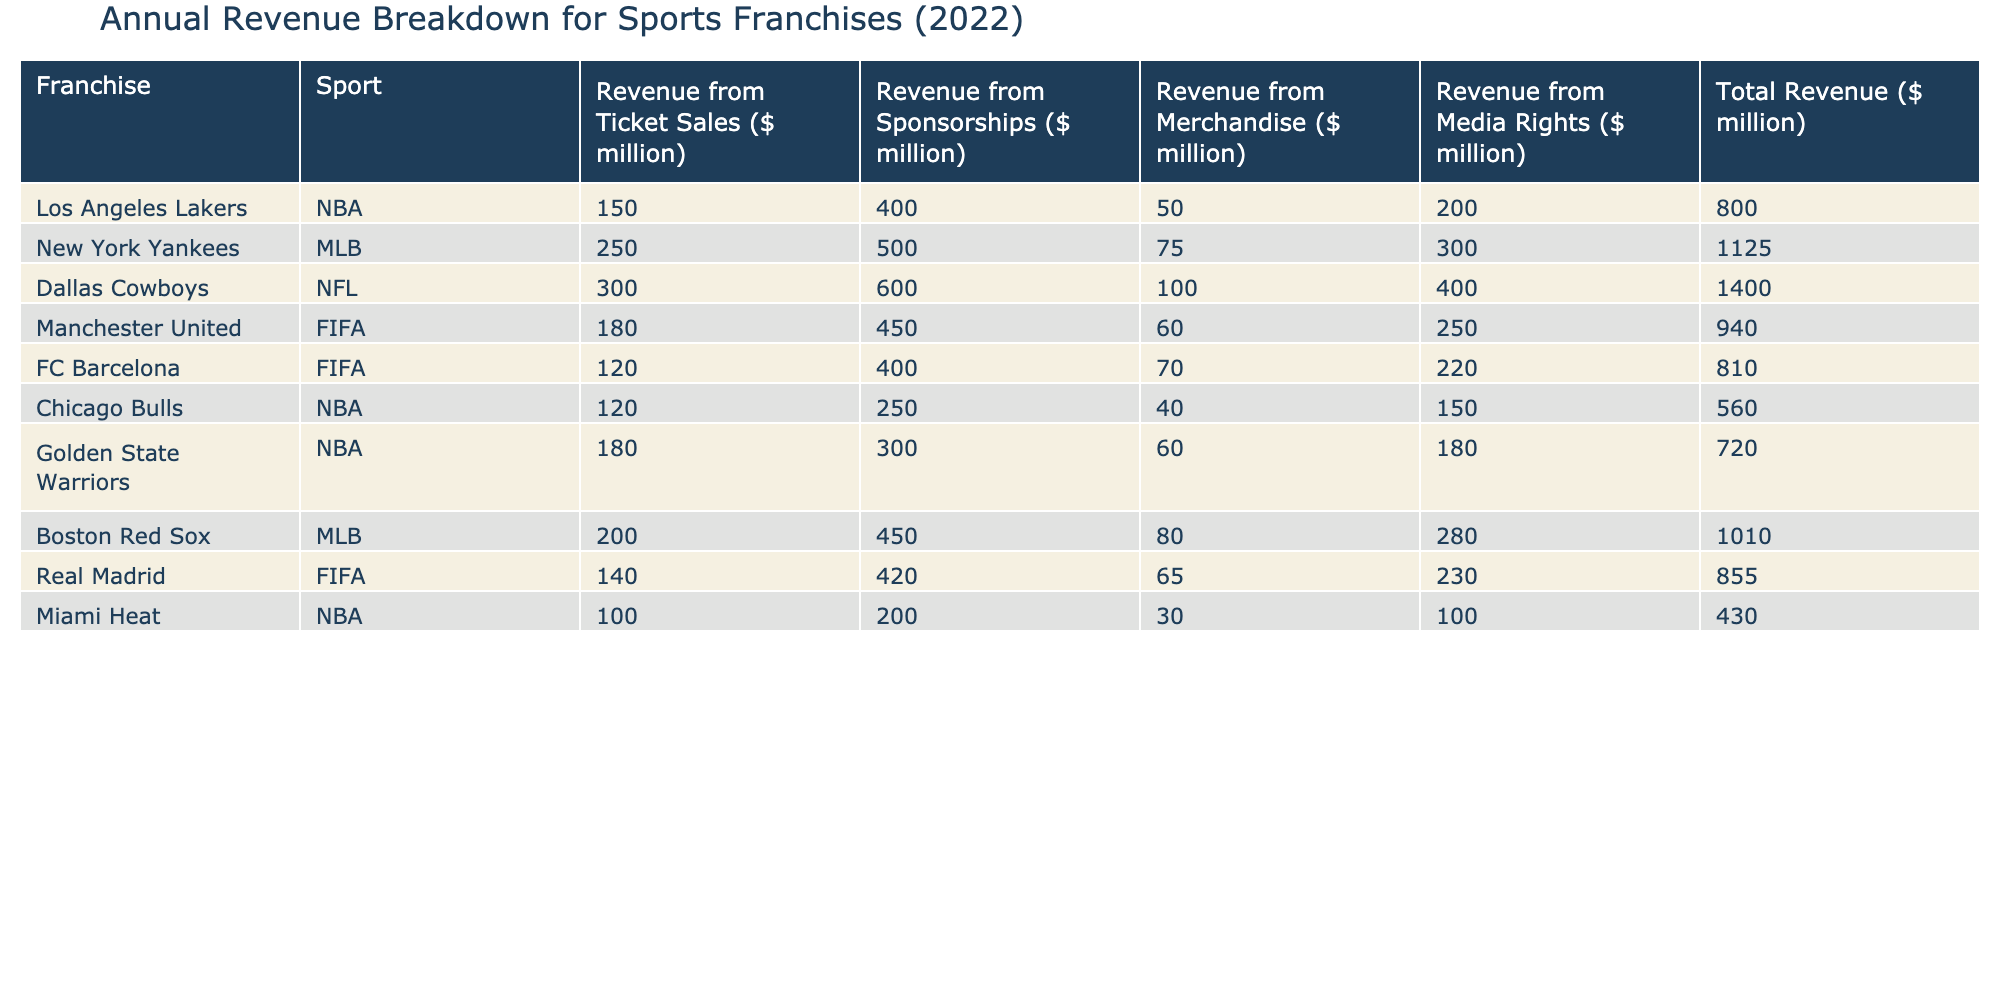What is the total revenue for the New York Yankees? The New York Yankees' total revenue is provided in the table under the column "Total Revenue," which shows it is 1125 million dollars.
Answer: 1125 million dollars Which franchise has the highest revenue from merchandise sales? By examining the "Revenue from Merchandise" column, the franchise with the highest value is the Boston Red Sox, with revenue of 80 million dollars.
Answer: Boston Red Sox What is the combined revenue from ticket sales for NBA franchises? The ticket sales revenue for NBA franchises (Los Angeles Lakers, Chicago Bulls, Golden State Warriors, and Miami Heat) is calculated as follows: 150 + 120 + 180 + 100 = 550 million dollars.
Answer: 550 million dollars Is the revenue from media rights for FC Barcelona greater than the revenue from media rights for the Miami Heat? Reviewing the "Revenue from Media Rights" column, FC Barcelona has 220 million dollars, while Miami Heat has 100 million dollars, thus FC Barcelona's revenue is indeed greater.
Answer: Yes What is the average revenue from sponsorships for FIFA franchises? To find the average revenue from sponsorships for FIFA franchises (Manchester United, FC Barcelona, and Real Madrid), we sum their sponsorship revenues: 450 + 400 + 420 = 1270 million dollars. Then, divide by the number of franchises: 1270 / 3 = approximately 423.33 million dollars.
Answer: Approximately 423.33 million dollars Which NBA franchise has the lowest total revenue? By examining the "Total Revenue" column, the franchise with the lowest value is the Miami Heat, which has a total revenue of 430 million dollars.
Answer: Miami Heat How much greater is the revenue from ticket sales for the Dallas Cowboys compared to that of the Chicago Bulls? The ticket sales for Dallas Cowboys is 300 million dollars, while for Chicago Bulls it is 120 million dollars. The difference is 300 - 120 = 180 million dollars, meaning the Cowboys have 180 million dollars more from ticket sales.
Answer: 180 million dollars Which sport franchise generates the most revenue from sponsorships? Evaluating the "Revenue from Sponsorships" column, the franchise that generates the most is the Dallas Cowboys, with a revenue of 600 million dollars from sponsorships.
Answer: Dallas Cowboys 